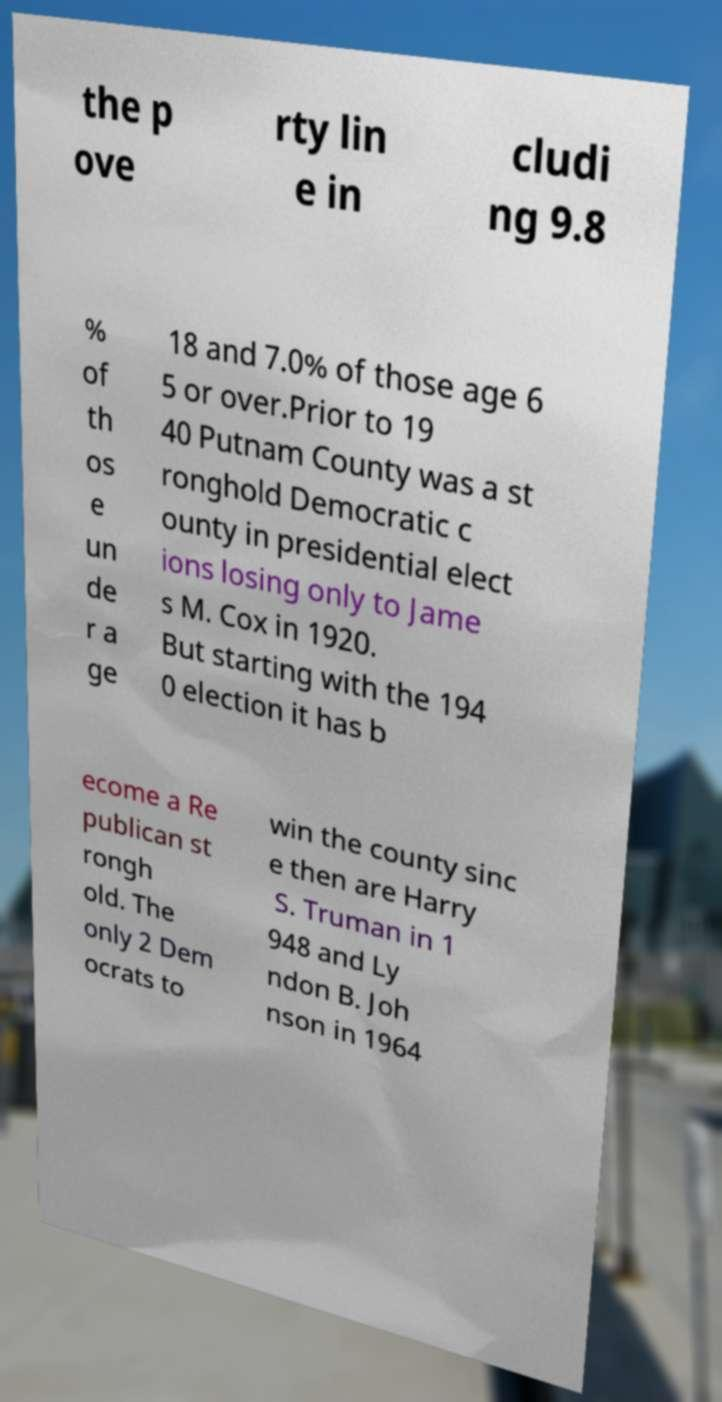Could you extract and type out the text from this image? the p ove rty lin e in cludi ng 9.8 % of th os e un de r a ge 18 and 7.0% of those age 6 5 or over.Prior to 19 40 Putnam County was a st ronghold Democratic c ounty in presidential elect ions losing only to Jame s M. Cox in 1920. But starting with the 194 0 election it has b ecome a Re publican st rongh old. The only 2 Dem ocrats to win the county sinc e then are Harry S. Truman in 1 948 and Ly ndon B. Joh nson in 1964 